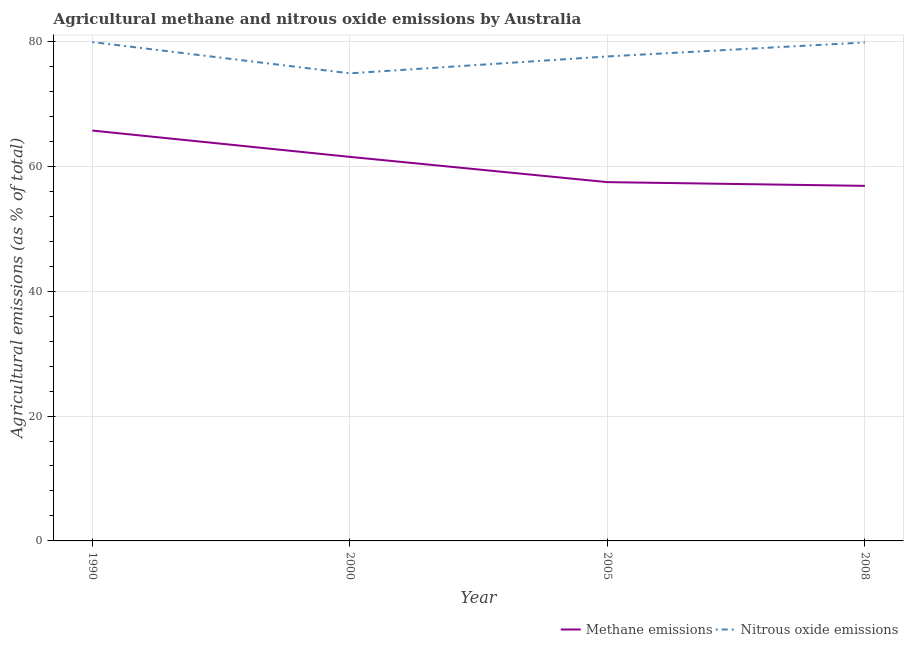Does the line corresponding to amount of nitrous oxide emissions intersect with the line corresponding to amount of methane emissions?
Your answer should be very brief. No. What is the amount of nitrous oxide emissions in 1990?
Keep it short and to the point. 79.88. Across all years, what is the maximum amount of methane emissions?
Provide a succinct answer. 65.71. Across all years, what is the minimum amount of methane emissions?
Make the answer very short. 56.85. In which year was the amount of methane emissions maximum?
Your answer should be very brief. 1990. In which year was the amount of nitrous oxide emissions minimum?
Give a very brief answer. 2000. What is the total amount of nitrous oxide emissions in the graph?
Provide a short and direct response. 312.15. What is the difference between the amount of nitrous oxide emissions in 2005 and that in 2008?
Ensure brevity in your answer.  -2.24. What is the difference between the amount of methane emissions in 2008 and the amount of nitrous oxide emissions in 2005?
Offer a terse response. -20.72. What is the average amount of methane emissions per year?
Your answer should be compact. 60.38. In the year 1990, what is the difference between the amount of nitrous oxide emissions and amount of methane emissions?
Provide a short and direct response. 14.17. In how many years, is the amount of methane emissions greater than 76 %?
Your answer should be compact. 0. What is the ratio of the amount of nitrous oxide emissions in 1990 to that in 2000?
Provide a short and direct response. 1.07. Is the amount of methane emissions in 1990 less than that in 2005?
Offer a very short reply. No. Is the difference between the amount of methane emissions in 2000 and 2008 greater than the difference between the amount of nitrous oxide emissions in 2000 and 2008?
Make the answer very short. Yes. What is the difference between the highest and the second highest amount of methane emissions?
Keep it short and to the point. 4.21. What is the difference between the highest and the lowest amount of nitrous oxide emissions?
Offer a terse response. 5.01. Is the sum of the amount of nitrous oxide emissions in 2005 and 2008 greater than the maximum amount of methane emissions across all years?
Your answer should be compact. Yes. Is the amount of methane emissions strictly greater than the amount of nitrous oxide emissions over the years?
Offer a terse response. No. Is the amount of methane emissions strictly less than the amount of nitrous oxide emissions over the years?
Keep it short and to the point. Yes. What is the difference between two consecutive major ticks on the Y-axis?
Make the answer very short. 20. Are the values on the major ticks of Y-axis written in scientific E-notation?
Offer a very short reply. No. Does the graph contain any zero values?
Provide a short and direct response. No. Does the graph contain grids?
Give a very brief answer. Yes. How many legend labels are there?
Your answer should be very brief. 2. How are the legend labels stacked?
Offer a terse response. Horizontal. What is the title of the graph?
Make the answer very short. Agricultural methane and nitrous oxide emissions by Australia. What is the label or title of the Y-axis?
Make the answer very short. Agricultural emissions (as % of total). What is the Agricultural emissions (as % of total) of Methane emissions in 1990?
Keep it short and to the point. 65.71. What is the Agricultural emissions (as % of total) of Nitrous oxide emissions in 1990?
Provide a short and direct response. 79.88. What is the Agricultural emissions (as % of total) in Methane emissions in 2000?
Offer a terse response. 61.5. What is the Agricultural emissions (as % of total) of Nitrous oxide emissions in 2000?
Your answer should be compact. 74.87. What is the Agricultural emissions (as % of total) in Methane emissions in 2005?
Your answer should be compact. 57.45. What is the Agricultural emissions (as % of total) of Nitrous oxide emissions in 2005?
Your answer should be very brief. 77.58. What is the Agricultural emissions (as % of total) in Methane emissions in 2008?
Give a very brief answer. 56.85. What is the Agricultural emissions (as % of total) in Nitrous oxide emissions in 2008?
Offer a terse response. 79.82. Across all years, what is the maximum Agricultural emissions (as % of total) in Methane emissions?
Provide a short and direct response. 65.71. Across all years, what is the maximum Agricultural emissions (as % of total) in Nitrous oxide emissions?
Offer a very short reply. 79.88. Across all years, what is the minimum Agricultural emissions (as % of total) in Methane emissions?
Provide a short and direct response. 56.85. Across all years, what is the minimum Agricultural emissions (as % of total) in Nitrous oxide emissions?
Ensure brevity in your answer.  74.87. What is the total Agricultural emissions (as % of total) in Methane emissions in the graph?
Make the answer very short. 241.51. What is the total Agricultural emissions (as % of total) of Nitrous oxide emissions in the graph?
Your answer should be compact. 312.15. What is the difference between the Agricultural emissions (as % of total) in Methane emissions in 1990 and that in 2000?
Provide a succinct answer. 4.21. What is the difference between the Agricultural emissions (as % of total) in Nitrous oxide emissions in 1990 and that in 2000?
Make the answer very short. 5.01. What is the difference between the Agricultural emissions (as % of total) of Methane emissions in 1990 and that in 2005?
Give a very brief answer. 8.26. What is the difference between the Agricultural emissions (as % of total) in Nitrous oxide emissions in 1990 and that in 2005?
Provide a succinct answer. 2.3. What is the difference between the Agricultural emissions (as % of total) in Methane emissions in 1990 and that in 2008?
Your answer should be very brief. 8.85. What is the difference between the Agricultural emissions (as % of total) in Nitrous oxide emissions in 1990 and that in 2008?
Offer a terse response. 0.06. What is the difference between the Agricultural emissions (as % of total) of Methane emissions in 2000 and that in 2005?
Provide a short and direct response. 4.04. What is the difference between the Agricultural emissions (as % of total) of Nitrous oxide emissions in 2000 and that in 2005?
Give a very brief answer. -2.71. What is the difference between the Agricultural emissions (as % of total) of Methane emissions in 2000 and that in 2008?
Your answer should be compact. 4.64. What is the difference between the Agricultural emissions (as % of total) in Nitrous oxide emissions in 2000 and that in 2008?
Your answer should be very brief. -4.95. What is the difference between the Agricultural emissions (as % of total) of Methane emissions in 2005 and that in 2008?
Provide a succinct answer. 0.6. What is the difference between the Agricultural emissions (as % of total) of Nitrous oxide emissions in 2005 and that in 2008?
Your answer should be compact. -2.24. What is the difference between the Agricultural emissions (as % of total) in Methane emissions in 1990 and the Agricultural emissions (as % of total) in Nitrous oxide emissions in 2000?
Keep it short and to the point. -9.16. What is the difference between the Agricultural emissions (as % of total) in Methane emissions in 1990 and the Agricultural emissions (as % of total) in Nitrous oxide emissions in 2005?
Provide a succinct answer. -11.87. What is the difference between the Agricultural emissions (as % of total) in Methane emissions in 1990 and the Agricultural emissions (as % of total) in Nitrous oxide emissions in 2008?
Keep it short and to the point. -14.11. What is the difference between the Agricultural emissions (as % of total) of Methane emissions in 2000 and the Agricultural emissions (as % of total) of Nitrous oxide emissions in 2005?
Your answer should be very brief. -16.08. What is the difference between the Agricultural emissions (as % of total) in Methane emissions in 2000 and the Agricultural emissions (as % of total) in Nitrous oxide emissions in 2008?
Make the answer very short. -18.32. What is the difference between the Agricultural emissions (as % of total) of Methane emissions in 2005 and the Agricultural emissions (as % of total) of Nitrous oxide emissions in 2008?
Provide a short and direct response. -22.37. What is the average Agricultural emissions (as % of total) in Methane emissions per year?
Your answer should be very brief. 60.38. What is the average Agricultural emissions (as % of total) of Nitrous oxide emissions per year?
Give a very brief answer. 78.04. In the year 1990, what is the difference between the Agricultural emissions (as % of total) of Methane emissions and Agricultural emissions (as % of total) of Nitrous oxide emissions?
Provide a succinct answer. -14.17. In the year 2000, what is the difference between the Agricultural emissions (as % of total) of Methane emissions and Agricultural emissions (as % of total) of Nitrous oxide emissions?
Your response must be concise. -13.38. In the year 2005, what is the difference between the Agricultural emissions (as % of total) in Methane emissions and Agricultural emissions (as % of total) in Nitrous oxide emissions?
Give a very brief answer. -20.13. In the year 2008, what is the difference between the Agricultural emissions (as % of total) in Methane emissions and Agricultural emissions (as % of total) in Nitrous oxide emissions?
Give a very brief answer. -22.96. What is the ratio of the Agricultural emissions (as % of total) of Methane emissions in 1990 to that in 2000?
Keep it short and to the point. 1.07. What is the ratio of the Agricultural emissions (as % of total) of Nitrous oxide emissions in 1990 to that in 2000?
Your answer should be very brief. 1.07. What is the ratio of the Agricultural emissions (as % of total) in Methane emissions in 1990 to that in 2005?
Ensure brevity in your answer.  1.14. What is the ratio of the Agricultural emissions (as % of total) of Nitrous oxide emissions in 1990 to that in 2005?
Your answer should be compact. 1.03. What is the ratio of the Agricultural emissions (as % of total) in Methane emissions in 1990 to that in 2008?
Provide a succinct answer. 1.16. What is the ratio of the Agricultural emissions (as % of total) of Nitrous oxide emissions in 1990 to that in 2008?
Offer a very short reply. 1. What is the ratio of the Agricultural emissions (as % of total) in Methane emissions in 2000 to that in 2005?
Provide a succinct answer. 1.07. What is the ratio of the Agricultural emissions (as % of total) of Nitrous oxide emissions in 2000 to that in 2005?
Offer a terse response. 0.97. What is the ratio of the Agricultural emissions (as % of total) in Methane emissions in 2000 to that in 2008?
Offer a very short reply. 1.08. What is the ratio of the Agricultural emissions (as % of total) of Nitrous oxide emissions in 2000 to that in 2008?
Your answer should be very brief. 0.94. What is the ratio of the Agricultural emissions (as % of total) of Methane emissions in 2005 to that in 2008?
Keep it short and to the point. 1.01. What is the ratio of the Agricultural emissions (as % of total) in Nitrous oxide emissions in 2005 to that in 2008?
Give a very brief answer. 0.97. What is the difference between the highest and the second highest Agricultural emissions (as % of total) in Methane emissions?
Provide a succinct answer. 4.21. What is the difference between the highest and the second highest Agricultural emissions (as % of total) in Nitrous oxide emissions?
Your answer should be very brief. 0.06. What is the difference between the highest and the lowest Agricultural emissions (as % of total) of Methane emissions?
Keep it short and to the point. 8.85. What is the difference between the highest and the lowest Agricultural emissions (as % of total) of Nitrous oxide emissions?
Offer a terse response. 5.01. 